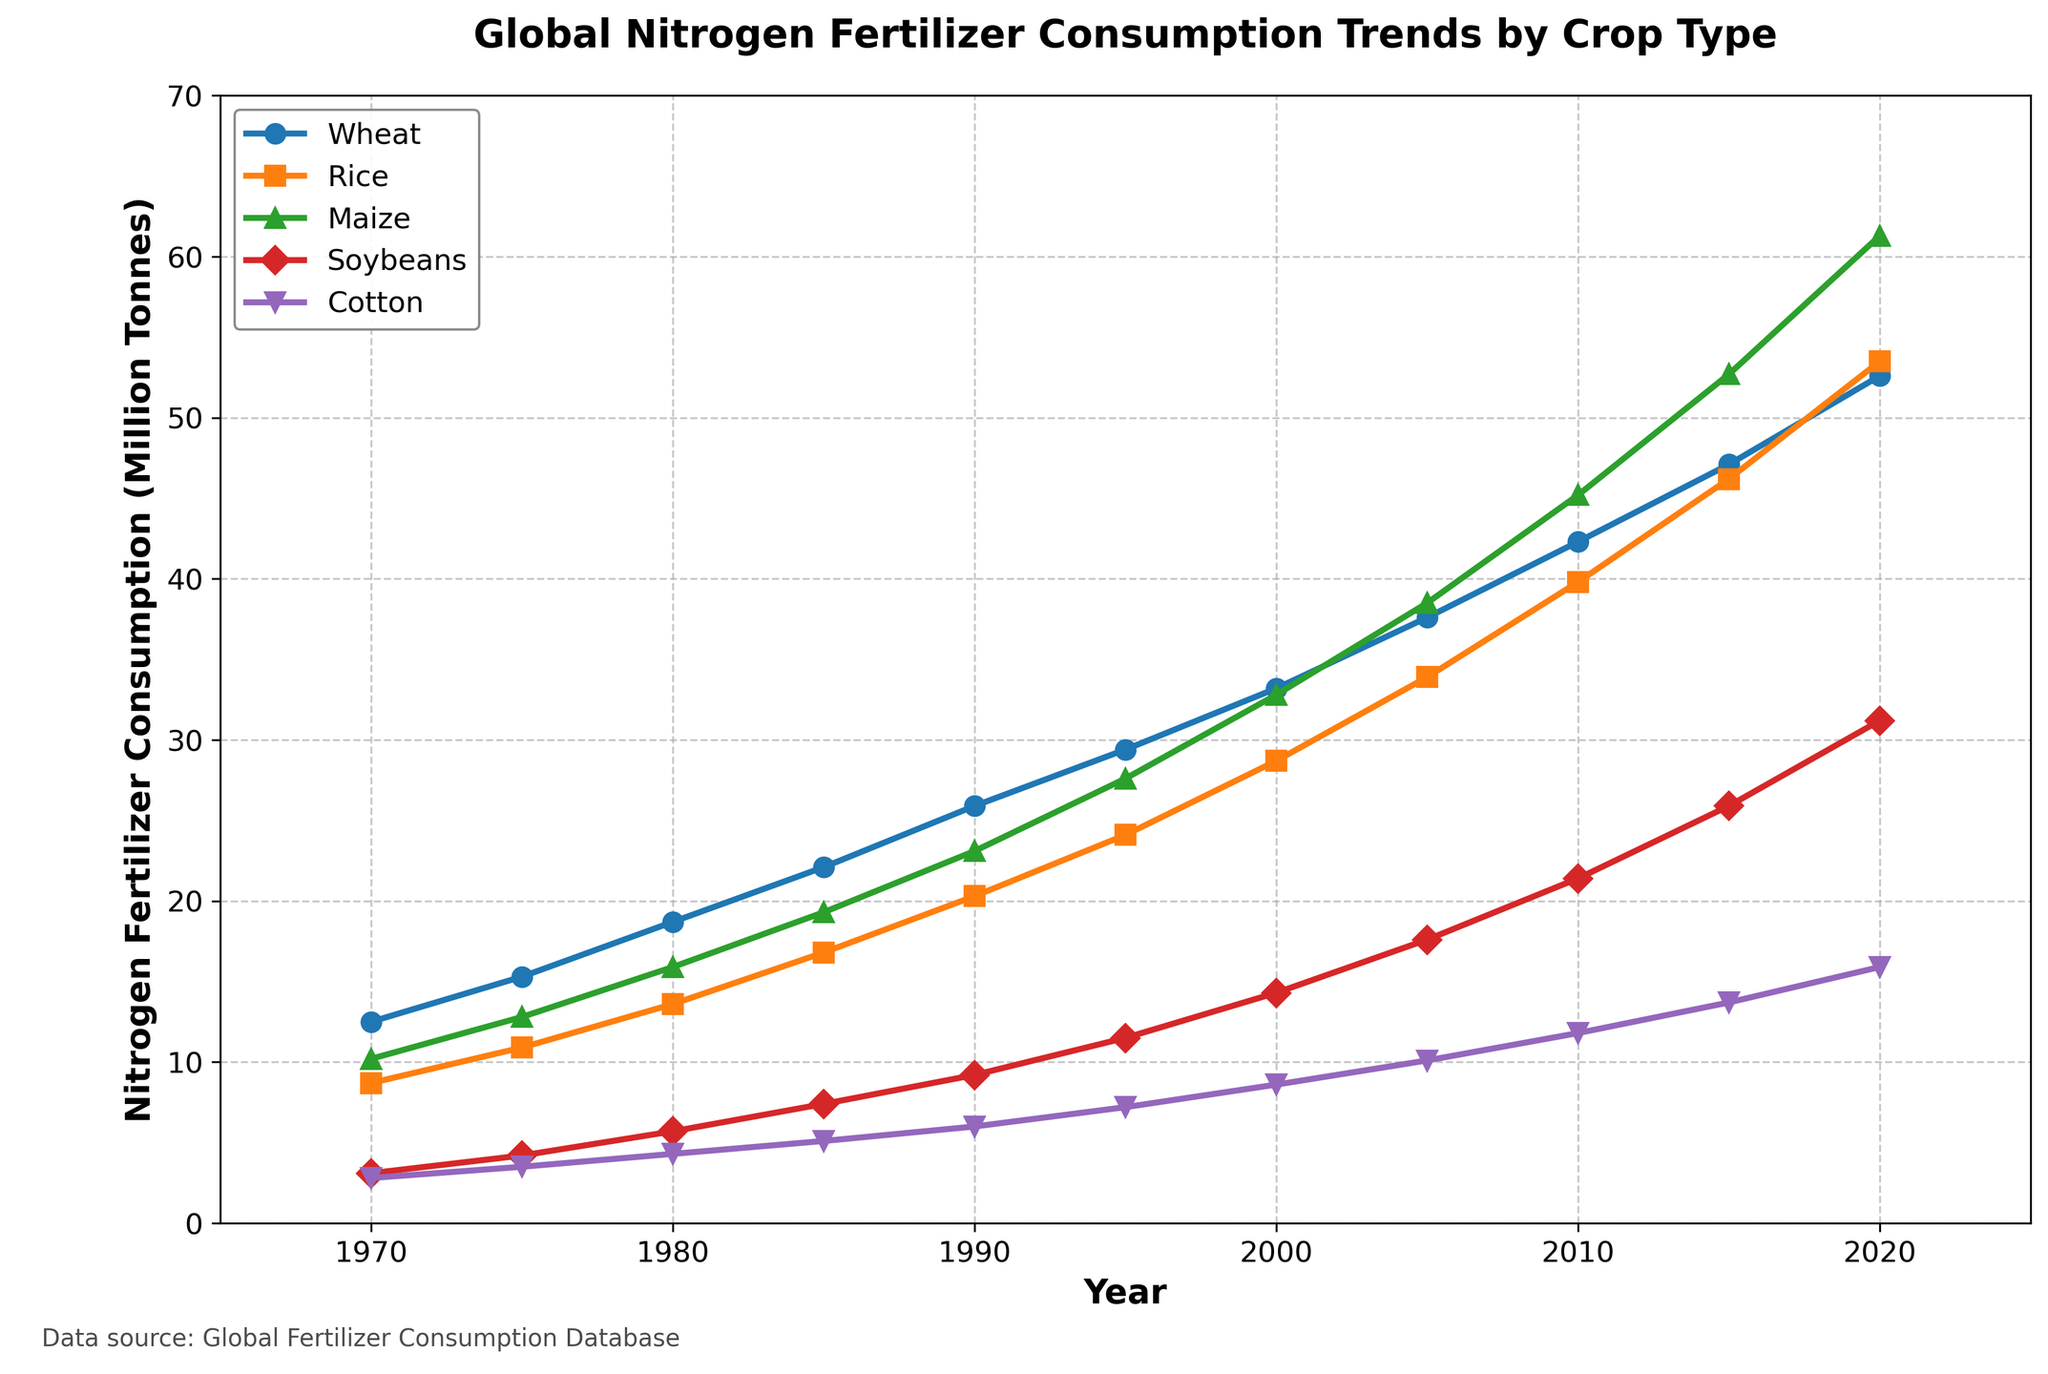What's the total nitrogen fertilizer consumption for Wheat and Rice in 1980? Add the nitrogen fertilizer consumption for Wheat and Rice in 1980: 18.7 (Wheat) + 13.6 (Rice) = 32.3
Answer: 32.3 Which crop type had the highest nitrogen fertilizer consumption in 2020? Compare the nitrogen fertilizer consumption values for all crop types in 2020: Wheat (52.6), Rice (53.5), Maize (61.3), Soybeans (31.2), Cotton (15.9). Maize has the highest value at 61.3
Answer: Maize By how much did nitrogen fertilizer consumption for Soybeans increase from 1970 to 2020? Subtract the nitrogen fertilizer consumption for Soybeans in 1970 from the value in 2020: 31.2 (2020) - 3.1 (1970) = 28.1
Answer: 28.1 What is the average nitrogen fertilizer consumption for Maize over the 50-year period? Sum the nitrogen fertilizer consumption values for Maize over all the years and divide by the total number of years: (10.2 + 12.8 + 15.9 + 19.3 + 23.1 + 27.6 + 32.8 + 38.5 + 45.2 + 52.7 + 61.3) / 11 = 30.9
Answer: 30.9 Which crop type showed the least increase in nitrogen fertilizer consumption from 1970 to 2020? Calculate the increase in nitrogen fertilizer consumption for each crop type from 1970 to 2020: Wheat (52.6 - 12.5 = 40.1), Rice (53.5 - 8.7 = 44.8), Maize (61.3 - 10.2 = 51.1), Soybeans (31.2 - 3.1 = 28.1), Cotton (15.9 - 2.8 = 13.1). Cotton showed the least increase at 13.1
Answer: Cotton In what year did nitrogen fertilizer consumption for Maize surpass 30 million tonnes? Identify the year when Maize's nitrogen fertilizer consumption first exceeded 30 million tonnes by examining the graph: The data point for Maize first surpasses 30 million tonnes in the year 2000
Answer: 2000 How does nitrogen fertilizer consumption for Wheat in 1995 compare to that for Cotton in the same year? Compare the nitrogen fertilizer consumption values for Wheat and Cotton in 1995: Wheat (29.4), Cotton (7.2). Wheat's value is higher than Cotton's
Answer: Wheat is higher By what percentage did nitrogen fertilizer consumption for Cotton increase from 1980 to 2000? Calculate the percentage increase for Cotton from 1980 to 2000: ((8.6 - 4.3) / 4.3) * 100 = 100%
Answer: 100% What are the visual indications of the crop type with the highest nitrogen fertilizer consumption in 2020? Identify the crop type (Maize) with the highest value and note its visual representation (green color, triangle markers)
Answer: Green color with triangle markers Is the trend of nitrogen fertilizer consumption for Rice increasing, decreasing, or stable over the period shown? Observe the line representing Rice's nitrogen fertilizer consumption which consistently rises from 1970 to 2020, indicating an increasing trend
Answer: Increasing 